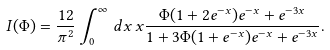Convert formula to latex. <formula><loc_0><loc_0><loc_500><loc_500>I ( \Phi ) = \frac { 1 2 } { \pi ^ { 2 } } \int _ { 0 } ^ { \infty } \, d x \, x \frac { \Phi ( 1 + 2 e ^ { - x } ) e ^ { - x } + e ^ { - 3 x } } { 1 + 3 \Phi ( 1 + e ^ { - x } ) e ^ { - x } + e ^ { - 3 x } } .</formula> 